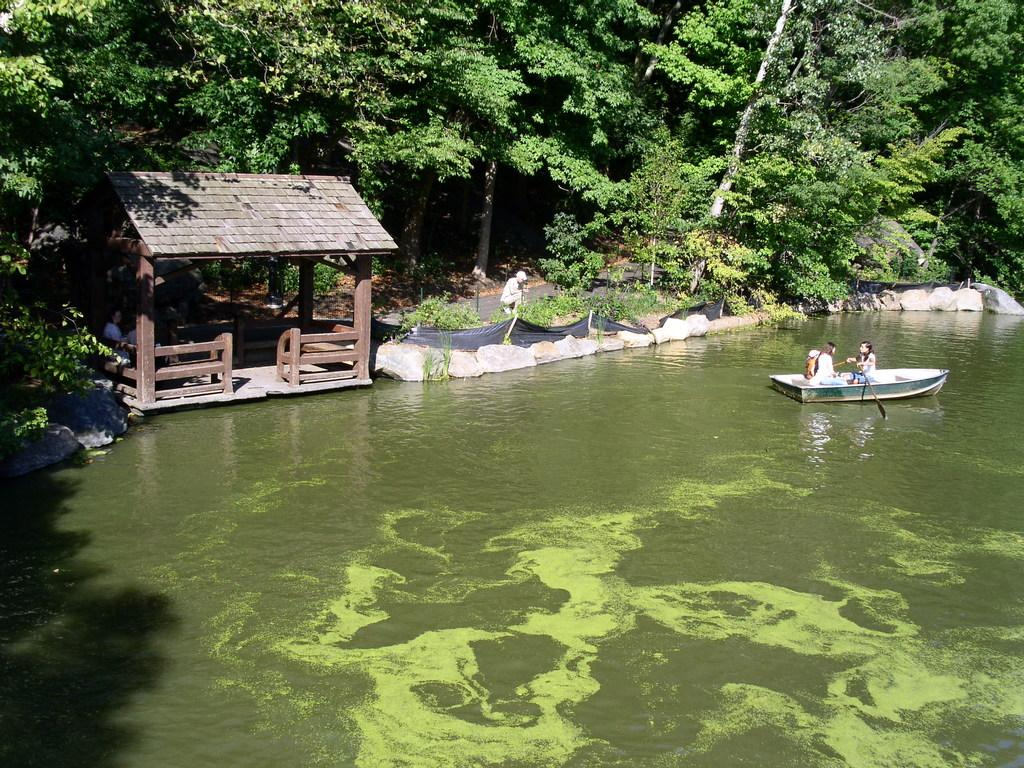What is the primary element present in the image? There is water in the image. What are the people in the image doing? The people are in a boat in the image. What type of vegetation can be seen in the image? There are trees in the image. What is the position of the person in the image? A person is standing in the image. What type of heat source can be seen in the image? There is no heat source present in the image. What is the frame made of in the image? There is no frame present in the image. 